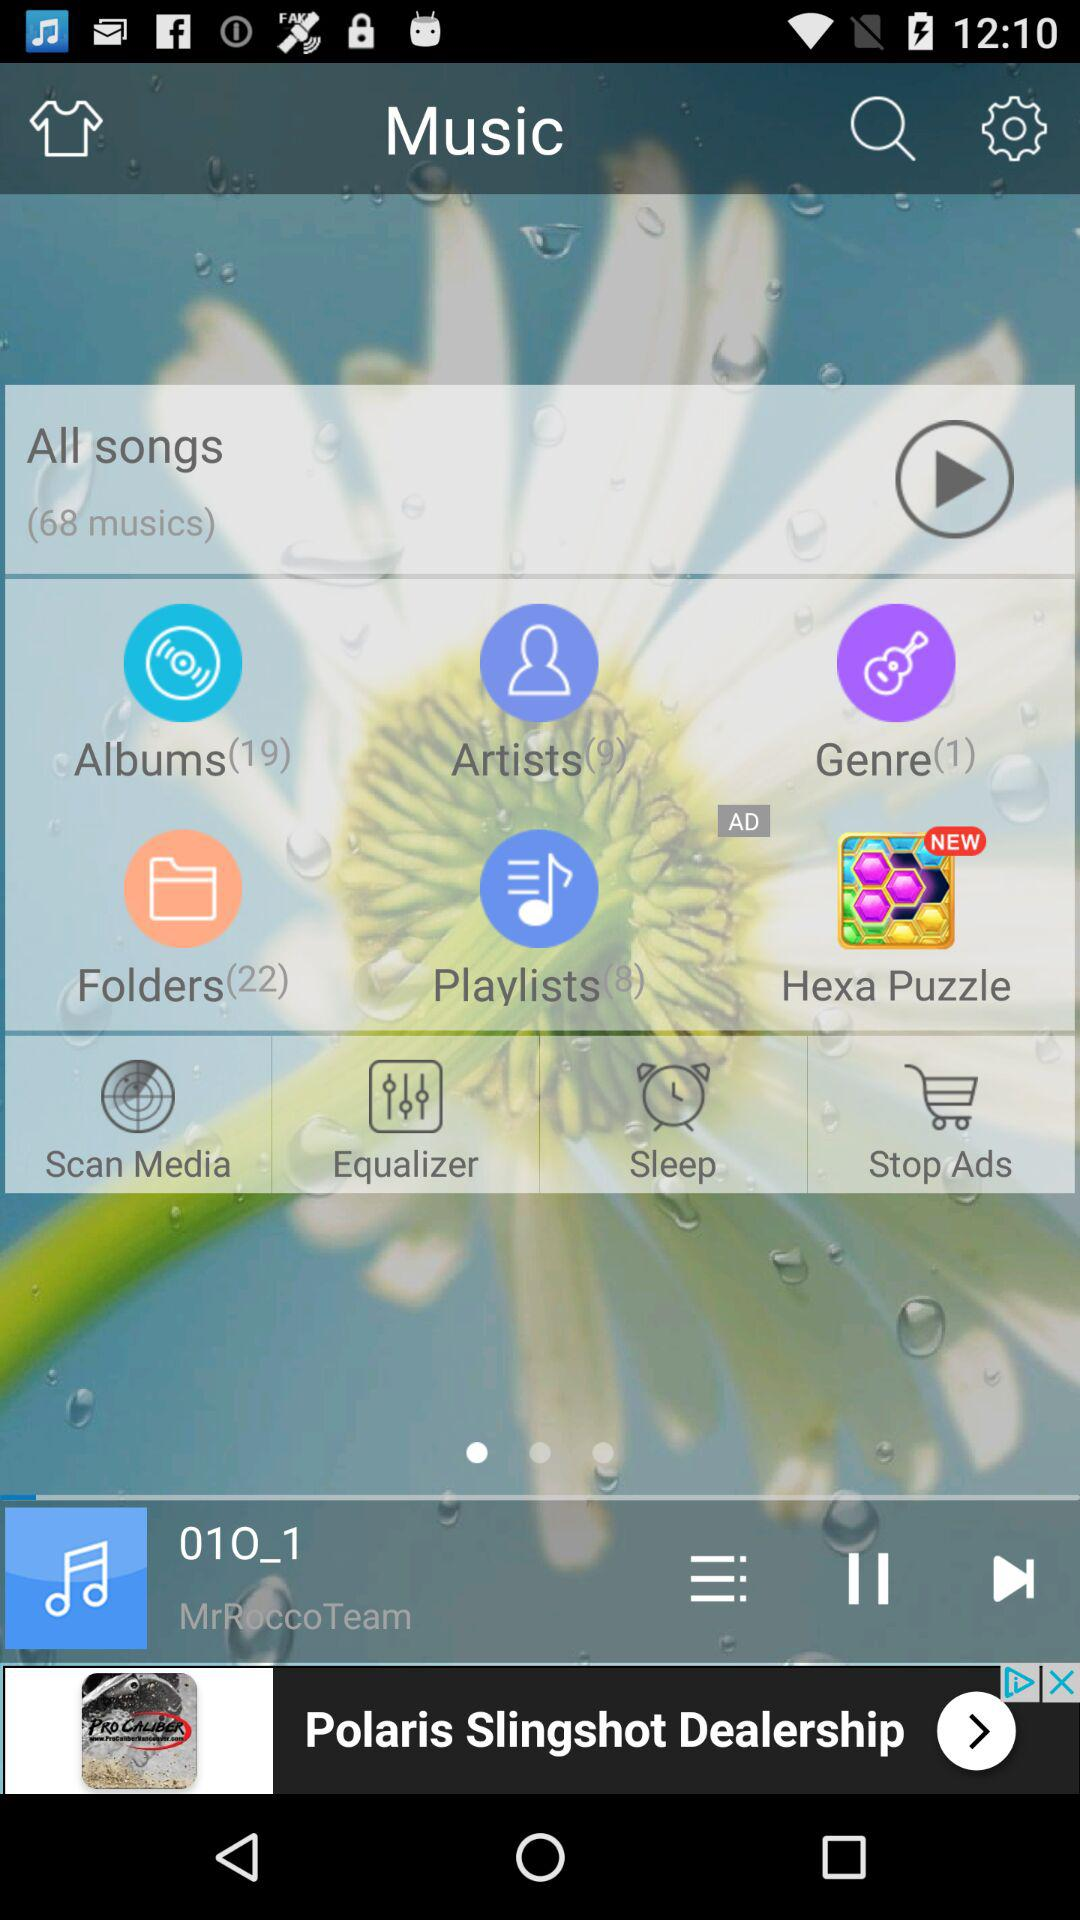How many items are in the music library?
Answer the question using a single word or phrase. 68 